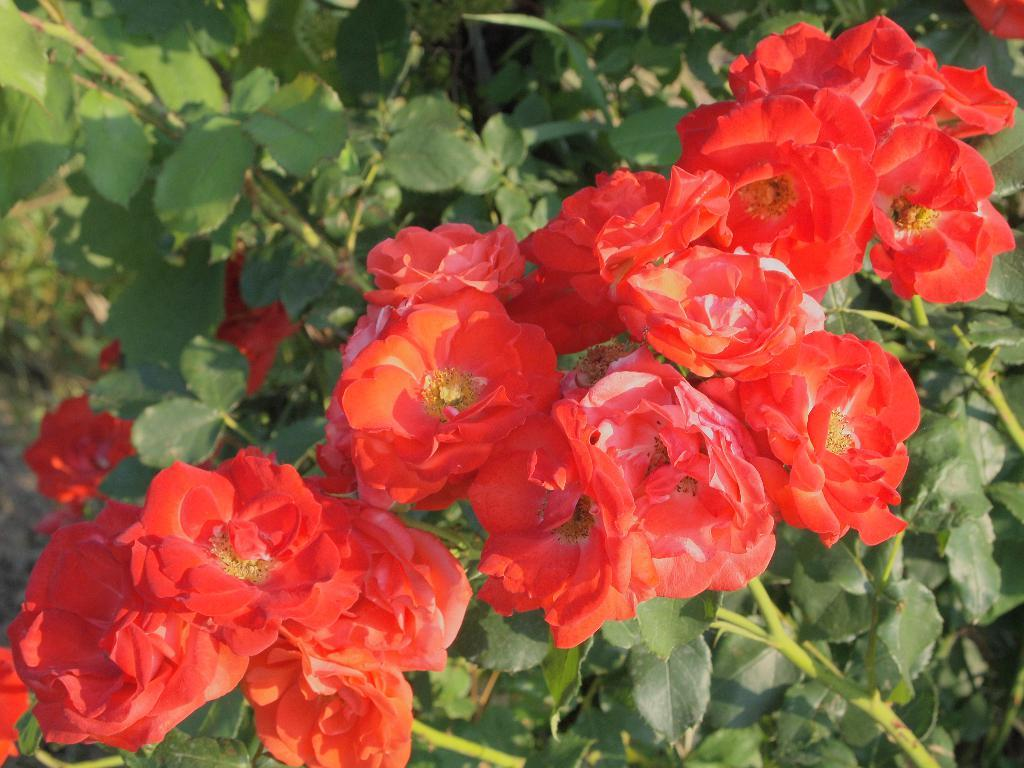What type of living organisms can be seen in the image? There are flowers and plants in the image. Can you describe the plants in the image? The plants in the image are not specified, but they are present alongside the flowers. What type of skin condition can be seen on the flowers in the image? There is no skin condition present on the flowers in the image, as flowers do not have skin. 